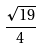Convert formula to latex. <formula><loc_0><loc_0><loc_500><loc_500>\frac { \sqrt { 1 9 } } { 4 }</formula> 